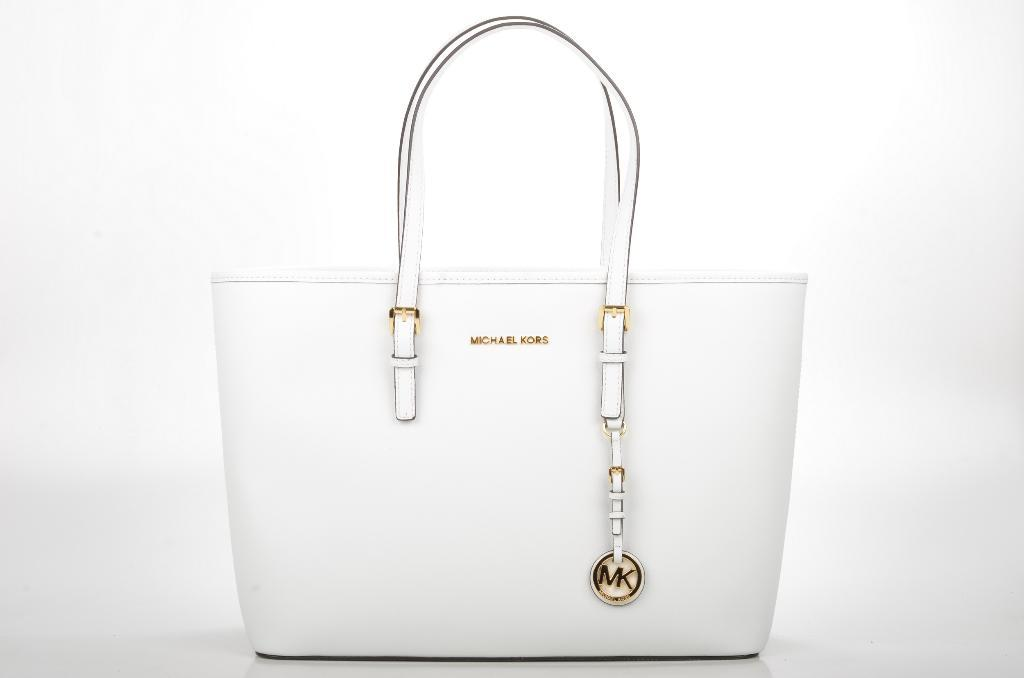What type of object is visible in the image? The object is a handbag. What color is the handbag? The handbag is white in color. What type of flower is growing on the edge of the handbag in the image? There is no flower present on the edge of the handbag in the image. 